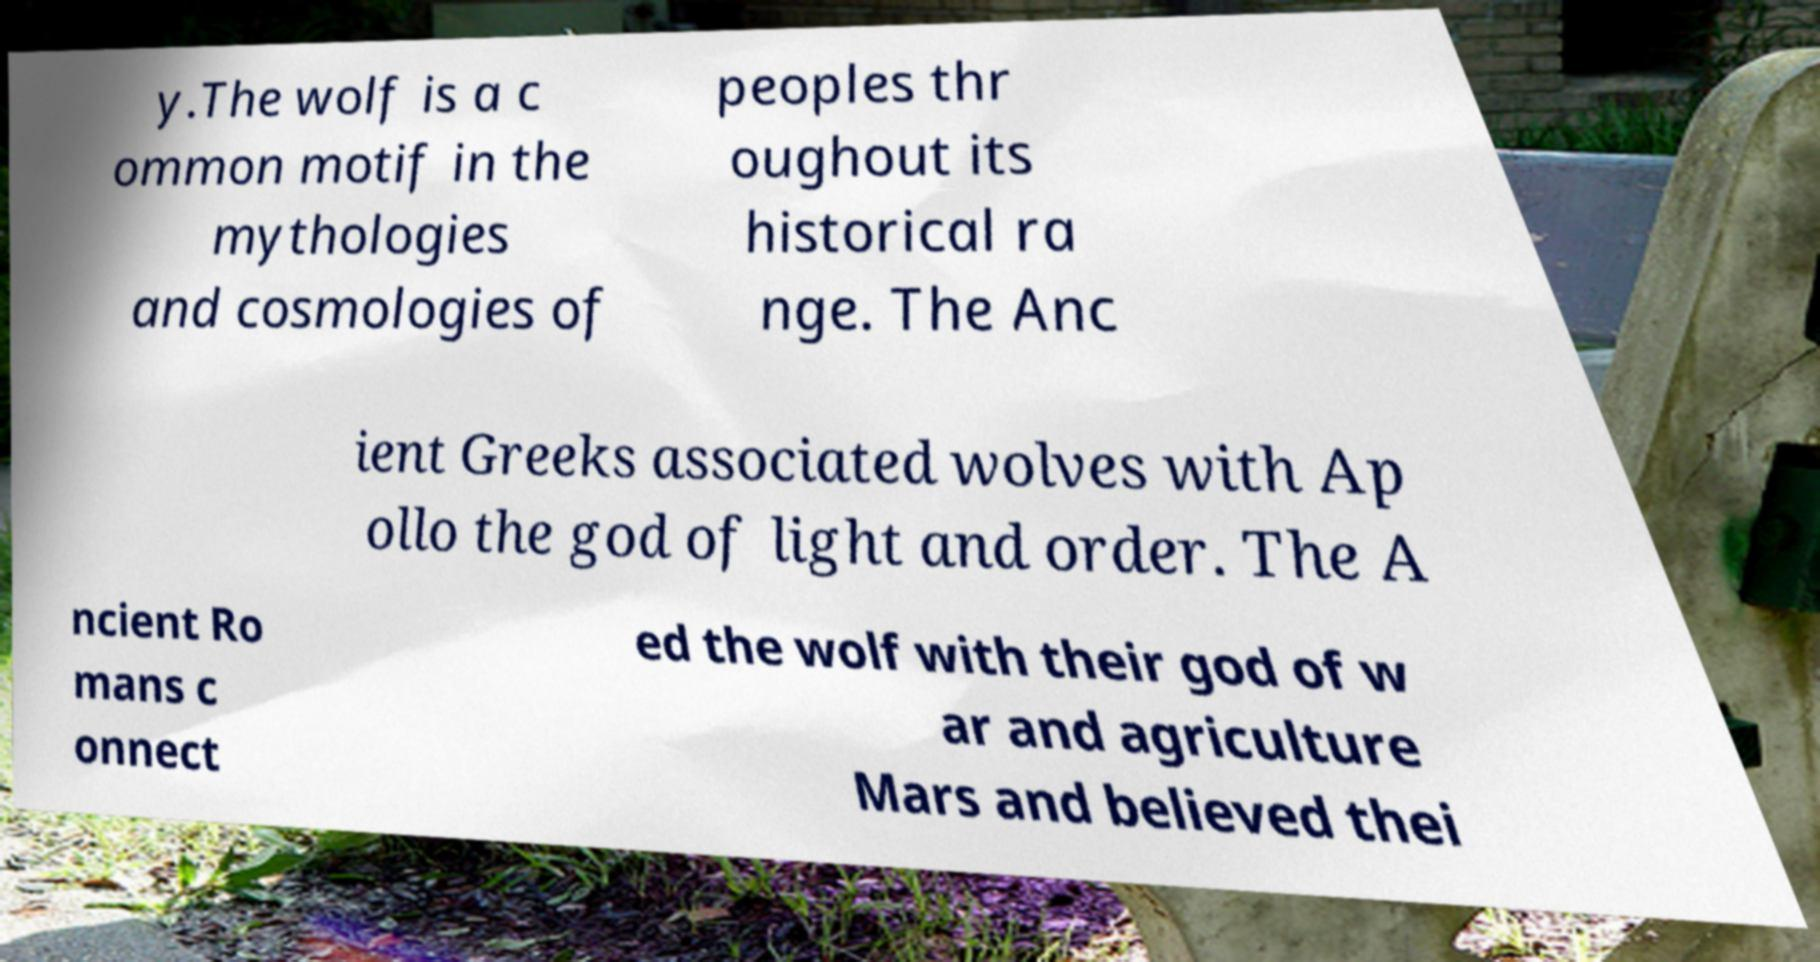Please read and relay the text visible in this image. What does it say? y.The wolf is a c ommon motif in the mythologies and cosmologies of peoples thr oughout its historical ra nge. The Anc ient Greeks associated wolves with Ap ollo the god of light and order. The A ncient Ro mans c onnect ed the wolf with their god of w ar and agriculture Mars and believed thei 